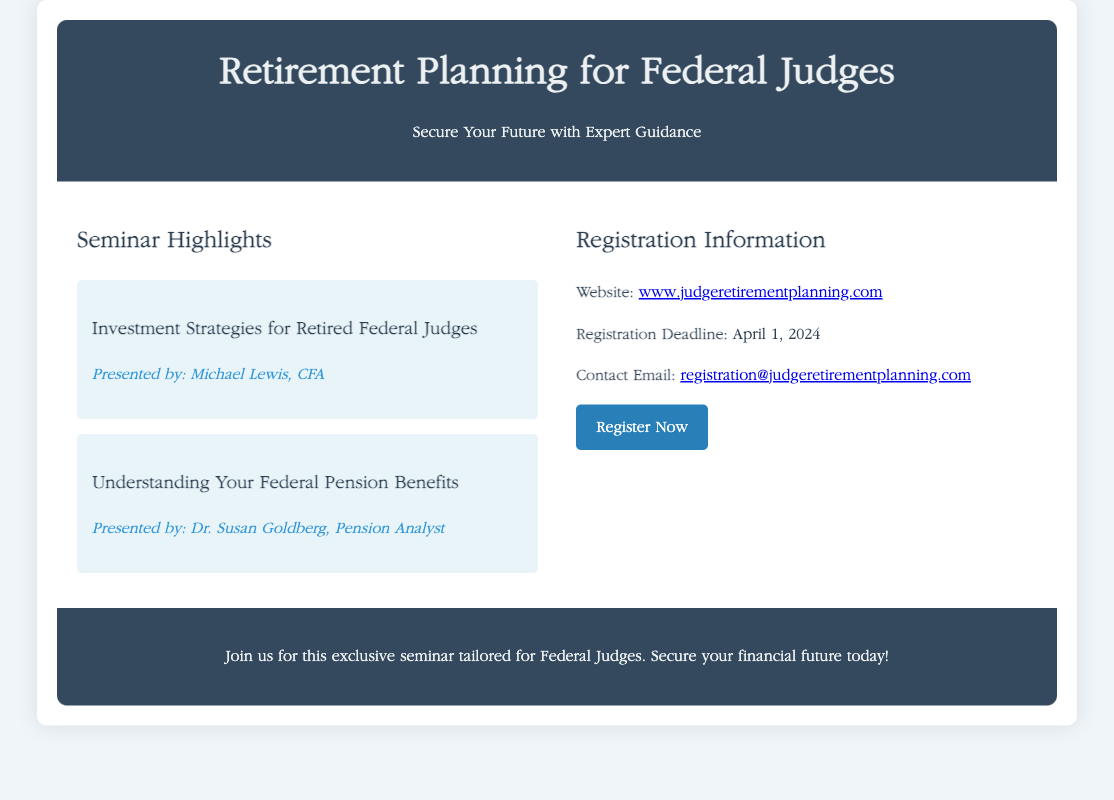What is the title of the seminar? The title of the seminar is specified in the document's header section, which is "Retirement Planning for Federal Judges."
Answer: Retirement Planning for Federal Judges Who is the speaker for the investment strategies session? The speaker for the investment strategies session is listed in the seminar details section as Michael Lewis, CFA.
Answer: Michael Lewis, CFA What is the registration deadline? The registration deadline is mentioned in the registration information section of the document as April 1, 2024.
Answer: April 1, 2024 What is the website for registration? The website for registration is provided in the contact information section, which is a link to www.judgeretirementplanning.com.
Answer: www.judgeretirementplanning.com How many seminar topics are highlighted in the document? The document contains two seminar topics highlighted in the seminar details section.
Answer: Two Why is this seminar specifically tailored for Federal Judges? The seminar is described as exclusive for Federal Judges, emphasizing the security of their financial future with expert guidance, indicated in the footer.
Answer: Expert guidance What visual theme is used in the document? The document presents a visually calming color scheme along with elegant layout and professional font styles, as specified in the style section.
Answer: Calming color schemes What type of advertisement is this document? The content of the document focuses on a seminar, making it an advertisement for an educational event.
Answer: Educational event 